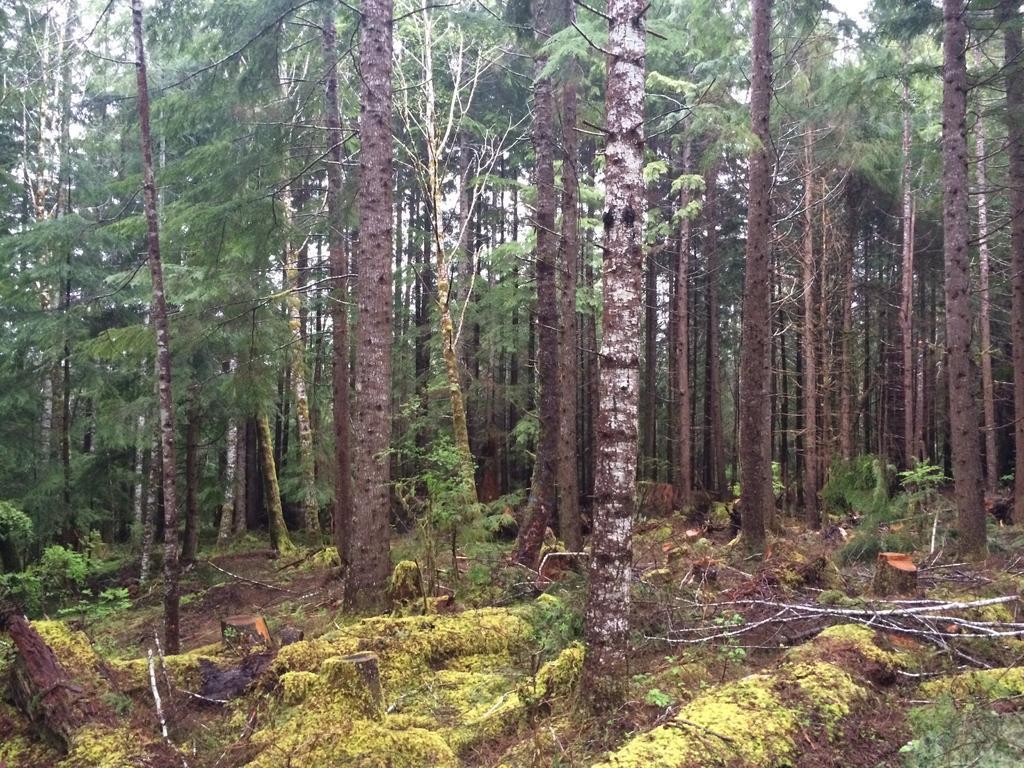Could you give a brief overview of what you see in this image? There are trees and dry sticks in the image. 